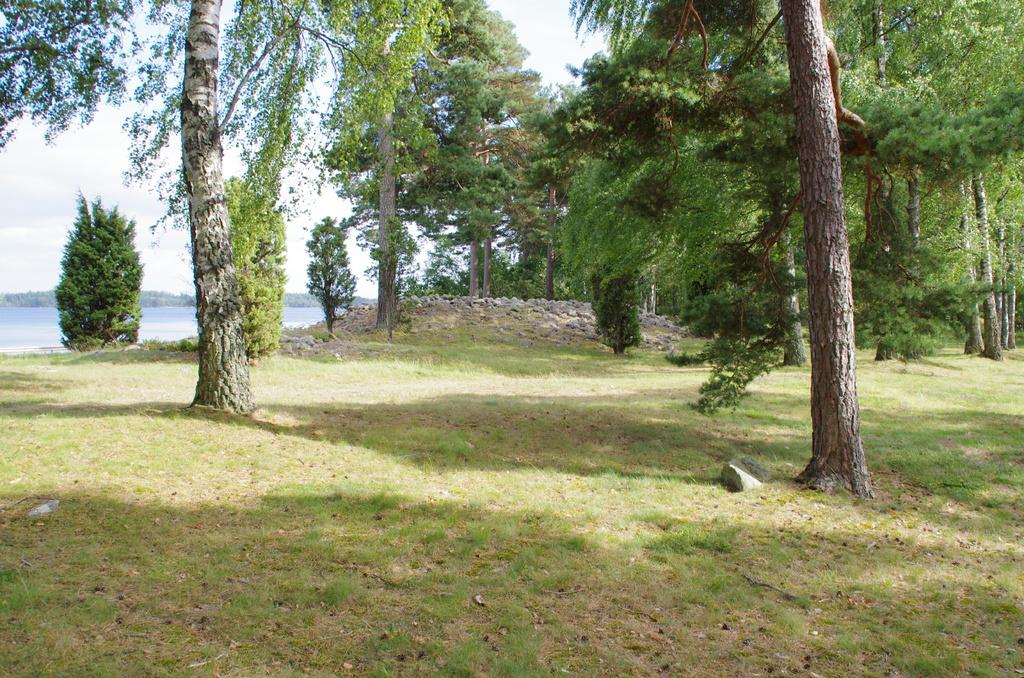What type of vegetation can be seen in the image? There are trees in the image. What other natural elements are present in the image? There are stones and grass visible in the image. What can be seen in the background of the image? The sky is visible in the background of the image. What is the condition of the sky in the image? There are clouds in the sky in the image. What type of insurance policy is being discussed by the trees in the image? There are no trees or any other subjects in the image that could discuss an insurance policy. Can you see a boot on any of the stones in the image? There is no boot present in the image; it only features trees, stones, grass, and the sky. 